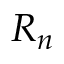<formula> <loc_0><loc_0><loc_500><loc_500>R _ { n }</formula> 